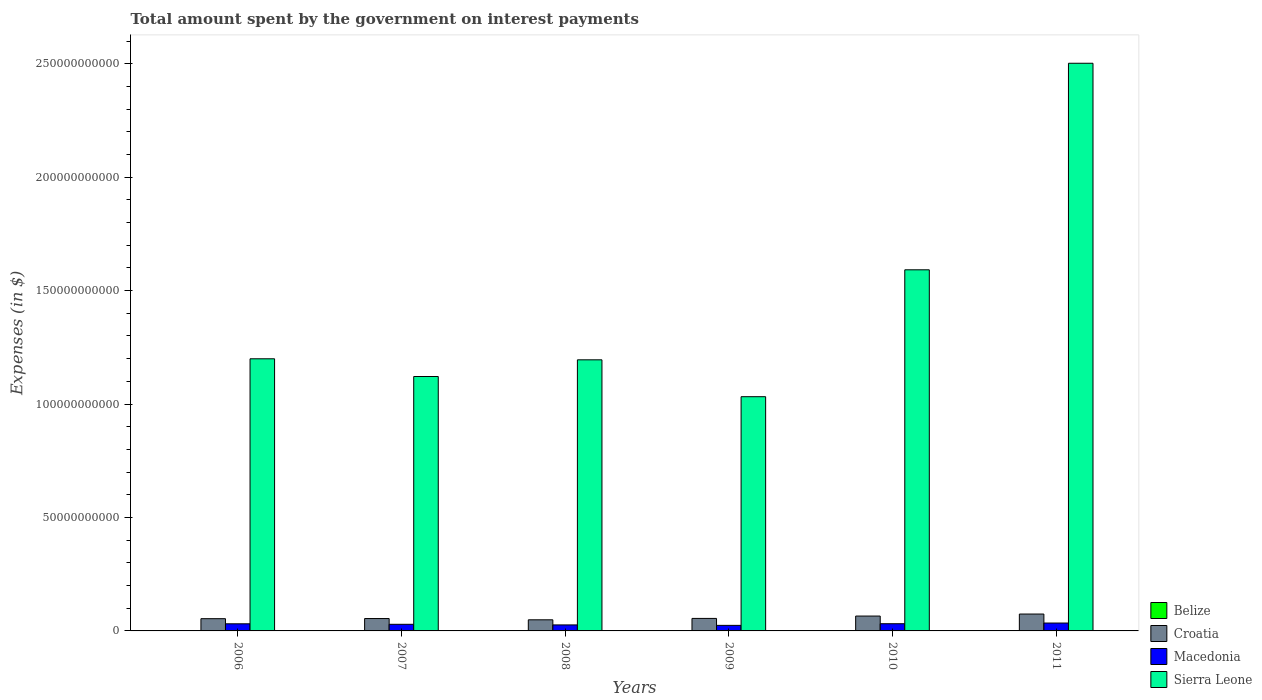How many different coloured bars are there?
Offer a terse response. 4. What is the label of the 6th group of bars from the left?
Provide a short and direct response. 2011. What is the amount spent on interest payments by the government in Sierra Leone in 2008?
Keep it short and to the point. 1.19e+11. Across all years, what is the maximum amount spent on interest payments by the government in Macedonia?
Your answer should be compact. 3.47e+09. Across all years, what is the minimum amount spent on interest payments by the government in Sierra Leone?
Your answer should be compact. 1.03e+11. In which year was the amount spent on interest payments by the government in Croatia maximum?
Give a very brief answer. 2011. What is the total amount spent on interest payments by the government in Croatia in the graph?
Give a very brief answer. 3.53e+1. What is the difference between the amount spent on interest payments by the government in Belize in 2007 and that in 2010?
Your answer should be compact. 7.81e+06. What is the difference between the amount spent on interest payments by the government in Croatia in 2007 and the amount spent on interest payments by the government in Macedonia in 2011?
Provide a short and direct response. 1.99e+09. What is the average amount spent on interest payments by the government in Macedonia per year?
Ensure brevity in your answer.  2.97e+09. In the year 2011, what is the difference between the amount spent on interest payments by the government in Croatia and amount spent on interest payments by the government in Macedonia?
Keep it short and to the point. 3.97e+09. In how many years, is the amount spent on interest payments by the government in Croatia greater than 200000000000 $?
Offer a very short reply. 0. What is the ratio of the amount spent on interest payments by the government in Belize in 2008 to that in 2011?
Give a very brief answer. 1. What is the difference between the highest and the second highest amount spent on interest payments by the government in Croatia?
Your answer should be very brief. 8.93e+08. What is the difference between the highest and the lowest amount spent on interest payments by the government in Croatia?
Keep it short and to the point. 2.54e+09. In how many years, is the amount spent on interest payments by the government in Belize greater than the average amount spent on interest payments by the government in Belize taken over all years?
Your response must be concise. 1. Is the sum of the amount spent on interest payments by the government in Sierra Leone in 2007 and 2008 greater than the maximum amount spent on interest payments by the government in Belize across all years?
Keep it short and to the point. Yes. Is it the case that in every year, the sum of the amount spent on interest payments by the government in Belize and amount spent on interest payments by the government in Sierra Leone is greater than the sum of amount spent on interest payments by the government in Croatia and amount spent on interest payments by the government in Macedonia?
Your answer should be very brief. Yes. What does the 2nd bar from the left in 2010 represents?
Ensure brevity in your answer.  Croatia. What does the 2nd bar from the right in 2006 represents?
Your answer should be compact. Macedonia. Are all the bars in the graph horizontal?
Make the answer very short. No. How many legend labels are there?
Provide a short and direct response. 4. What is the title of the graph?
Give a very brief answer. Total amount spent by the government on interest payments. Does "Djibouti" appear as one of the legend labels in the graph?
Your answer should be very brief. No. What is the label or title of the Y-axis?
Provide a short and direct response. Expenses (in $). What is the Expenses (in $) of Belize in 2006?
Make the answer very short. 1.70e+08. What is the Expenses (in $) in Croatia in 2006?
Your response must be concise. 5.40e+09. What is the Expenses (in $) in Macedonia in 2006?
Your response must be concise. 3.14e+09. What is the Expenses (in $) in Sierra Leone in 2006?
Offer a terse response. 1.20e+11. What is the Expenses (in $) in Belize in 2007?
Your answer should be very brief. 1.11e+08. What is the Expenses (in $) in Croatia in 2007?
Your response must be concise. 5.46e+09. What is the Expenses (in $) of Macedonia in 2007?
Ensure brevity in your answer.  2.92e+09. What is the Expenses (in $) of Sierra Leone in 2007?
Provide a succinct answer. 1.12e+11. What is the Expenses (in $) of Belize in 2008?
Offer a very short reply. 1.02e+08. What is the Expenses (in $) in Croatia in 2008?
Provide a succinct answer. 4.90e+09. What is the Expenses (in $) in Macedonia in 2008?
Ensure brevity in your answer.  2.65e+09. What is the Expenses (in $) of Sierra Leone in 2008?
Your answer should be very brief. 1.19e+11. What is the Expenses (in $) in Belize in 2009?
Make the answer very short. 9.58e+07. What is the Expenses (in $) in Croatia in 2009?
Your answer should be very brief. 5.51e+09. What is the Expenses (in $) in Macedonia in 2009?
Keep it short and to the point. 2.44e+09. What is the Expenses (in $) in Sierra Leone in 2009?
Ensure brevity in your answer.  1.03e+11. What is the Expenses (in $) in Belize in 2010?
Keep it short and to the point. 1.03e+08. What is the Expenses (in $) in Croatia in 2010?
Your answer should be compact. 6.55e+09. What is the Expenses (in $) in Macedonia in 2010?
Provide a short and direct response. 3.17e+09. What is the Expenses (in $) in Sierra Leone in 2010?
Your answer should be very brief. 1.59e+11. What is the Expenses (in $) of Belize in 2011?
Give a very brief answer. 1.02e+08. What is the Expenses (in $) in Croatia in 2011?
Your response must be concise. 7.44e+09. What is the Expenses (in $) in Macedonia in 2011?
Give a very brief answer. 3.47e+09. What is the Expenses (in $) in Sierra Leone in 2011?
Your response must be concise. 2.50e+11. Across all years, what is the maximum Expenses (in $) of Belize?
Your answer should be very brief. 1.70e+08. Across all years, what is the maximum Expenses (in $) in Croatia?
Offer a very short reply. 7.44e+09. Across all years, what is the maximum Expenses (in $) of Macedonia?
Your answer should be compact. 3.47e+09. Across all years, what is the maximum Expenses (in $) of Sierra Leone?
Offer a very short reply. 2.50e+11. Across all years, what is the minimum Expenses (in $) of Belize?
Your response must be concise. 9.58e+07. Across all years, what is the minimum Expenses (in $) in Croatia?
Your response must be concise. 4.90e+09. Across all years, what is the minimum Expenses (in $) in Macedonia?
Ensure brevity in your answer.  2.44e+09. Across all years, what is the minimum Expenses (in $) of Sierra Leone?
Offer a very short reply. 1.03e+11. What is the total Expenses (in $) of Belize in the graph?
Offer a very short reply. 6.85e+08. What is the total Expenses (in $) in Croatia in the graph?
Offer a very short reply. 3.53e+1. What is the total Expenses (in $) in Macedonia in the graph?
Offer a terse response. 1.78e+1. What is the total Expenses (in $) in Sierra Leone in the graph?
Offer a terse response. 8.64e+11. What is the difference between the Expenses (in $) in Belize in 2006 and that in 2007?
Keep it short and to the point. 5.90e+07. What is the difference between the Expenses (in $) in Croatia in 2006 and that in 2007?
Give a very brief answer. -6.40e+07. What is the difference between the Expenses (in $) in Macedonia in 2006 and that in 2007?
Offer a terse response. 2.22e+08. What is the difference between the Expenses (in $) in Sierra Leone in 2006 and that in 2007?
Give a very brief answer. 7.81e+09. What is the difference between the Expenses (in $) in Belize in 2006 and that in 2008?
Your answer should be compact. 6.79e+07. What is the difference between the Expenses (in $) of Croatia in 2006 and that in 2008?
Your answer should be very brief. 4.96e+08. What is the difference between the Expenses (in $) in Macedonia in 2006 and that in 2008?
Offer a terse response. 4.94e+08. What is the difference between the Expenses (in $) of Sierra Leone in 2006 and that in 2008?
Your answer should be compact. 4.59e+08. What is the difference between the Expenses (in $) of Belize in 2006 and that in 2009?
Your answer should be compact. 7.44e+07. What is the difference between the Expenses (in $) of Croatia in 2006 and that in 2009?
Ensure brevity in your answer.  -1.13e+08. What is the difference between the Expenses (in $) of Macedonia in 2006 and that in 2009?
Offer a very short reply. 6.95e+08. What is the difference between the Expenses (in $) in Sierra Leone in 2006 and that in 2009?
Offer a very short reply. 1.67e+1. What is the difference between the Expenses (in $) in Belize in 2006 and that in 2010?
Provide a succinct answer. 6.68e+07. What is the difference between the Expenses (in $) in Croatia in 2006 and that in 2010?
Give a very brief answer. -1.15e+09. What is the difference between the Expenses (in $) of Macedonia in 2006 and that in 2010?
Offer a very short reply. -3.39e+07. What is the difference between the Expenses (in $) in Sierra Leone in 2006 and that in 2010?
Keep it short and to the point. -3.92e+1. What is the difference between the Expenses (in $) of Belize in 2006 and that in 2011?
Provide a short and direct response. 6.79e+07. What is the difference between the Expenses (in $) of Croatia in 2006 and that in 2011?
Provide a succinct answer. -2.05e+09. What is the difference between the Expenses (in $) of Macedonia in 2006 and that in 2011?
Your response must be concise. -3.31e+08. What is the difference between the Expenses (in $) of Sierra Leone in 2006 and that in 2011?
Give a very brief answer. -1.30e+11. What is the difference between the Expenses (in $) of Belize in 2007 and that in 2008?
Keep it short and to the point. 8.84e+06. What is the difference between the Expenses (in $) of Croatia in 2007 and that in 2008?
Your answer should be compact. 5.60e+08. What is the difference between the Expenses (in $) in Macedonia in 2007 and that in 2008?
Make the answer very short. 2.72e+08. What is the difference between the Expenses (in $) of Sierra Leone in 2007 and that in 2008?
Offer a terse response. -7.35e+09. What is the difference between the Expenses (in $) in Belize in 2007 and that in 2009?
Offer a very short reply. 1.54e+07. What is the difference between the Expenses (in $) of Croatia in 2007 and that in 2009?
Ensure brevity in your answer.  -4.88e+07. What is the difference between the Expenses (in $) in Macedonia in 2007 and that in 2009?
Give a very brief answer. 4.73e+08. What is the difference between the Expenses (in $) of Sierra Leone in 2007 and that in 2009?
Your answer should be compact. 8.90e+09. What is the difference between the Expenses (in $) of Belize in 2007 and that in 2010?
Provide a short and direct response. 7.81e+06. What is the difference between the Expenses (in $) of Croatia in 2007 and that in 2010?
Give a very brief answer. -1.09e+09. What is the difference between the Expenses (in $) of Macedonia in 2007 and that in 2010?
Provide a short and direct response. -2.56e+08. What is the difference between the Expenses (in $) in Sierra Leone in 2007 and that in 2010?
Your response must be concise. -4.70e+1. What is the difference between the Expenses (in $) in Belize in 2007 and that in 2011?
Your response must be concise. 8.85e+06. What is the difference between the Expenses (in $) of Croatia in 2007 and that in 2011?
Provide a short and direct response. -1.98e+09. What is the difference between the Expenses (in $) of Macedonia in 2007 and that in 2011?
Your response must be concise. -5.53e+08. What is the difference between the Expenses (in $) of Sierra Leone in 2007 and that in 2011?
Keep it short and to the point. -1.38e+11. What is the difference between the Expenses (in $) of Belize in 2008 and that in 2009?
Your answer should be compact. 6.55e+06. What is the difference between the Expenses (in $) in Croatia in 2008 and that in 2009?
Provide a short and direct response. -6.09e+08. What is the difference between the Expenses (in $) in Macedonia in 2008 and that in 2009?
Provide a succinct answer. 2.01e+08. What is the difference between the Expenses (in $) of Sierra Leone in 2008 and that in 2009?
Your response must be concise. 1.62e+1. What is the difference between the Expenses (in $) in Belize in 2008 and that in 2010?
Offer a very short reply. -1.03e+06. What is the difference between the Expenses (in $) of Croatia in 2008 and that in 2010?
Keep it short and to the point. -1.65e+09. What is the difference between the Expenses (in $) in Macedonia in 2008 and that in 2010?
Provide a short and direct response. -5.28e+08. What is the difference between the Expenses (in $) in Sierra Leone in 2008 and that in 2010?
Keep it short and to the point. -3.97e+1. What is the difference between the Expenses (in $) of Belize in 2008 and that in 2011?
Make the answer very short. 2000. What is the difference between the Expenses (in $) in Croatia in 2008 and that in 2011?
Offer a terse response. -2.54e+09. What is the difference between the Expenses (in $) in Macedonia in 2008 and that in 2011?
Your answer should be compact. -8.25e+08. What is the difference between the Expenses (in $) in Sierra Leone in 2008 and that in 2011?
Offer a terse response. -1.31e+11. What is the difference between the Expenses (in $) of Belize in 2009 and that in 2010?
Make the answer very short. -7.59e+06. What is the difference between the Expenses (in $) of Croatia in 2009 and that in 2010?
Make the answer very short. -1.04e+09. What is the difference between the Expenses (in $) in Macedonia in 2009 and that in 2010?
Ensure brevity in your answer.  -7.29e+08. What is the difference between the Expenses (in $) in Sierra Leone in 2009 and that in 2010?
Ensure brevity in your answer.  -5.59e+1. What is the difference between the Expenses (in $) in Belize in 2009 and that in 2011?
Offer a terse response. -6.55e+06. What is the difference between the Expenses (in $) in Croatia in 2009 and that in 2011?
Make the answer very short. -1.93e+09. What is the difference between the Expenses (in $) in Macedonia in 2009 and that in 2011?
Provide a short and direct response. -1.03e+09. What is the difference between the Expenses (in $) of Sierra Leone in 2009 and that in 2011?
Provide a short and direct response. -1.47e+11. What is the difference between the Expenses (in $) of Belize in 2010 and that in 2011?
Make the answer very short. 1.03e+06. What is the difference between the Expenses (in $) of Croatia in 2010 and that in 2011?
Make the answer very short. -8.93e+08. What is the difference between the Expenses (in $) in Macedonia in 2010 and that in 2011?
Keep it short and to the point. -2.97e+08. What is the difference between the Expenses (in $) of Sierra Leone in 2010 and that in 2011?
Offer a very short reply. -9.10e+1. What is the difference between the Expenses (in $) in Belize in 2006 and the Expenses (in $) in Croatia in 2007?
Make the answer very short. -5.29e+09. What is the difference between the Expenses (in $) in Belize in 2006 and the Expenses (in $) in Macedonia in 2007?
Provide a short and direct response. -2.75e+09. What is the difference between the Expenses (in $) in Belize in 2006 and the Expenses (in $) in Sierra Leone in 2007?
Make the answer very short. -1.12e+11. What is the difference between the Expenses (in $) in Croatia in 2006 and the Expenses (in $) in Macedonia in 2007?
Make the answer very short. 2.48e+09. What is the difference between the Expenses (in $) in Croatia in 2006 and the Expenses (in $) in Sierra Leone in 2007?
Provide a short and direct response. -1.07e+11. What is the difference between the Expenses (in $) of Macedonia in 2006 and the Expenses (in $) of Sierra Leone in 2007?
Offer a terse response. -1.09e+11. What is the difference between the Expenses (in $) of Belize in 2006 and the Expenses (in $) of Croatia in 2008?
Keep it short and to the point. -4.73e+09. What is the difference between the Expenses (in $) of Belize in 2006 and the Expenses (in $) of Macedonia in 2008?
Provide a succinct answer. -2.48e+09. What is the difference between the Expenses (in $) of Belize in 2006 and the Expenses (in $) of Sierra Leone in 2008?
Ensure brevity in your answer.  -1.19e+11. What is the difference between the Expenses (in $) of Croatia in 2006 and the Expenses (in $) of Macedonia in 2008?
Ensure brevity in your answer.  2.75e+09. What is the difference between the Expenses (in $) in Croatia in 2006 and the Expenses (in $) in Sierra Leone in 2008?
Your answer should be compact. -1.14e+11. What is the difference between the Expenses (in $) of Macedonia in 2006 and the Expenses (in $) of Sierra Leone in 2008?
Make the answer very short. -1.16e+11. What is the difference between the Expenses (in $) of Belize in 2006 and the Expenses (in $) of Croatia in 2009?
Your answer should be very brief. -5.34e+09. What is the difference between the Expenses (in $) of Belize in 2006 and the Expenses (in $) of Macedonia in 2009?
Your response must be concise. -2.27e+09. What is the difference between the Expenses (in $) in Belize in 2006 and the Expenses (in $) in Sierra Leone in 2009?
Provide a succinct answer. -1.03e+11. What is the difference between the Expenses (in $) in Croatia in 2006 and the Expenses (in $) in Macedonia in 2009?
Your response must be concise. 2.95e+09. What is the difference between the Expenses (in $) of Croatia in 2006 and the Expenses (in $) of Sierra Leone in 2009?
Make the answer very short. -9.78e+1. What is the difference between the Expenses (in $) of Macedonia in 2006 and the Expenses (in $) of Sierra Leone in 2009?
Ensure brevity in your answer.  -1.00e+11. What is the difference between the Expenses (in $) in Belize in 2006 and the Expenses (in $) in Croatia in 2010?
Ensure brevity in your answer.  -6.38e+09. What is the difference between the Expenses (in $) of Belize in 2006 and the Expenses (in $) of Macedonia in 2010?
Make the answer very short. -3.00e+09. What is the difference between the Expenses (in $) of Belize in 2006 and the Expenses (in $) of Sierra Leone in 2010?
Provide a succinct answer. -1.59e+11. What is the difference between the Expenses (in $) in Croatia in 2006 and the Expenses (in $) in Macedonia in 2010?
Give a very brief answer. 2.22e+09. What is the difference between the Expenses (in $) of Croatia in 2006 and the Expenses (in $) of Sierra Leone in 2010?
Provide a short and direct response. -1.54e+11. What is the difference between the Expenses (in $) of Macedonia in 2006 and the Expenses (in $) of Sierra Leone in 2010?
Keep it short and to the point. -1.56e+11. What is the difference between the Expenses (in $) of Belize in 2006 and the Expenses (in $) of Croatia in 2011?
Offer a very short reply. -7.27e+09. What is the difference between the Expenses (in $) of Belize in 2006 and the Expenses (in $) of Macedonia in 2011?
Ensure brevity in your answer.  -3.30e+09. What is the difference between the Expenses (in $) in Belize in 2006 and the Expenses (in $) in Sierra Leone in 2011?
Your answer should be compact. -2.50e+11. What is the difference between the Expenses (in $) in Croatia in 2006 and the Expenses (in $) in Macedonia in 2011?
Ensure brevity in your answer.  1.93e+09. What is the difference between the Expenses (in $) of Croatia in 2006 and the Expenses (in $) of Sierra Leone in 2011?
Your response must be concise. -2.45e+11. What is the difference between the Expenses (in $) of Macedonia in 2006 and the Expenses (in $) of Sierra Leone in 2011?
Keep it short and to the point. -2.47e+11. What is the difference between the Expenses (in $) in Belize in 2007 and the Expenses (in $) in Croatia in 2008?
Keep it short and to the point. -4.79e+09. What is the difference between the Expenses (in $) of Belize in 2007 and the Expenses (in $) of Macedonia in 2008?
Offer a very short reply. -2.53e+09. What is the difference between the Expenses (in $) in Belize in 2007 and the Expenses (in $) in Sierra Leone in 2008?
Provide a succinct answer. -1.19e+11. What is the difference between the Expenses (in $) in Croatia in 2007 and the Expenses (in $) in Macedonia in 2008?
Offer a very short reply. 2.82e+09. What is the difference between the Expenses (in $) in Croatia in 2007 and the Expenses (in $) in Sierra Leone in 2008?
Your answer should be very brief. -1.14e+11. What is the difference between the Expenses (in $) in Macedonia in 2007 and the Expenses (in $) in Sierra Leone in 2008?
Your answer should be very brief. -1.17e+11. What is the difference between the Expenses (in $) of Belize in 2007 and the Expenses (in $) of Croatia in 2009?
Keep it short and to the point. -5.40e+09. What is the difference between the Expenses (in $) of Belize in 2007 and the Expenses (in $) of Macedonia in 2009?
Provide a short and direct response. -2.33e+09. What is the difference between the Expenses (in $) of Belize in 2007 and the Expenses (in $) of Sierra Leone in 2009?
Your answer should be very brief. -1.03e+11. What is the difference between the Expenses (in $) of Croatia in 2007 and the Expenses (in $) of Macedonia in 2009?
Provide a short and direct response. 3.02e+09. What is the difference between the Expenses (in $) of Croatia in 2007 and the Expenses (in $) of Sierra Leone in 2009?
Ensure brevity in your answer.  -9.78e+1. What is the difference between the Expenses (in $) in Macedonia in 2007 and the Expenses (in $) in Sierra Leone in 2009?
Provide a succinct answer. -1.00e+11. What is the difference between the Expenses (in $) in Belize in 2007 and the Expenses (in $) in Croatia in 2010?
Provide a succinct answer. -6.44e+09. What is the difference between the Expenses (in $) of Belize in 2007 and the Expenses (in $) of Macedonia in 2010?
Your answer should be very brief. -3.06e+09. What is the difference between the Expenses (in $) of Belize in 2007 and the Expenses (in $) of Sierra Leone in 2010?
Provide a short and direct response. -1.59e+11. What is the difference between the Expenses (in $) in Croatia in 2007 and the Expenses (in $) in Macedonia in 2010?
Your answer should be very brief. 2.29e+09. What is the difference between the Expenses (in $) of Croatia in 2007 and the Expenses (in $) of Sierra Leone in 2010?
Keep it short and to the point. -1.54e+11. What is the difference between the Expenses (in $) in Macedonia in 2007 and the Expenses (in $) in Sierra Leone in 2010?
Make the answer very short. -1.56e+11. What is the difference between the Expenses (in $) in Belize in 2007 and the Expenses (in $) in Croatia in 2011?
Your answer should be compact. -7.33e+09. What is the difference between the Expenses (in $) in Belize in 2007 and the Expenses (in $) in Macedonia in 2011?
Your response must be concise. -3.36e+09. What is the difference between the Expenses (in $) in Belize in 2007 and the Expenses (in $) in Sierra Leone in 2011?
Make the answer very short. -2.50e+11. What is the difference between the Expenses (in $) in Croatia in 2007 and the Expenses (in $) in Macedonia in 2011?
Provide a succinct answer. 1.99e+09. What is the difference between the Expenses (in $) of Croatia in 2007 and the Expenses (in $) of Sierra Leone in 2011?
Ensure brevity in your answer.  -2.45e+11. What is the difference between the Expenses (in $) of Macedonia in 2007 and the Expenses (in $) of Sierra Leone in 2011?
Offer a very short reply. -2.47e+11. What is the difference between the Expenses (in $) in Belize in 2008 and the Expenses (in $) in Croatia in 2009?
Your answer should be very brief. -5.41e+09. What is the difference between the Expenses (in $) in Belize in 2008 and the Expenses (in $) in Macedonia in 2009?
Your answer should be very brief. -2.34e+09. What is the difference between the Expenses (in $) of Belize in 2008 and the Expenses (in $) of Sierra Leone in 2009?
Keep it short and to the point. -1.03e+11. What is the difference between the Expenses (in $) of Croatia in 2008 and the Expenses (in $) of Macedonia in 2009?
Provide a short and direct response. 2.46e+09. What is the difference between the Expenses (in $) in Croatia in 2008 and the Expenses (in $) in Sierra Leone in 2009?
Make the answer very short. -9.83e+1. What is the difference between the Expenses (in $) of Macedonia in 2008 and the Expenses (in $) of Sierra Leone in 2009?
Give a very brief answer. -1.01e+11. What is the difference between the Expenses (in $) in Belize in 2008 and the Expenses (in $) in Croatia in 2010?
Keep it short and to the point. -6.45e+09. What is the difference between the Expenses (in $) in Belize in 2008 and the Expenses (in $) in Macedonia in 2010?
Your answer should be compact. -3.07e+09. What is the difference between the Expenses (in $) of Belize in 2008 and the Expenses (in $) of Sierra Leone in 2010?
Offer a very short reply. -1.59e+11. What is the difference between the Expenses (in $) in Croatia in 2008 and the Expenses (in $) in Macedonia in 2010?
Give a very brief answer. 1.73e+09. What is the difference between the Expenses (in $) in Croatia in 2008 and the Expenses (in $) in Sierra Leone in 2010?
Offer a very short reply. -1.54e+11. What is the difference between the Expenses (in $) in Macedonia in 2008 and the Expenses (in $) in Sierra Leone in 2010?
Provide a succinct answer. -1.57e+11. What is the difference between the Expenses (in $) of Belize in 2008 and the Expenses (in $) of Croatia in 2011?
Give a very brief answer. -7.34e+09. What is the difference between the Expenses (in $) of Belize in 2008 and the Expenses (in $) of Macedonia in 2011?
Offer a very short reply. -3.37e+09. What is the difference between the Expenses (in $) of Belize in 2008 and the Expenses (in $) of Sierra Leone in 2011?
Your answer should be compact. -2.50e+11. What is the difference between the Expenses (in $) in Croatia in 2008 and the Expenses (in $) in Macedonia in 2011?
Provide a succinct answer. 1.43e+09. What is the difference between the Expenses (in $) in Croatia in 2008 and the Expenses (in $) in Sierra Leone in 2011?
Ensure brevity in your answer.  -2.45e+11. What is the difference between the Expenses (in $) in Macedonia in 2008 and the Expenses (in $) in Sierra Leone in 2011?
Your response must be concise. -2.48e+11. What is the difference between the Expenses (in $) of Belize in 2009 and the Expenses (in $) of Croatia in 2010?
Ensure brevity in your answer.  -6.46e+09. What is the difference between the Expenses (in $) in Belize in 2009 and the Expenses (in $) in Macedonia in 2010?
Make the answer very short. -3.08e+09. What is the difference between the Expenses (in $) of Belize in 2009 and the Expenses (in $) of Sierra Leone in 2010?
Your answer should be very brief. -1.59e+11. What is the difference between the Expenses (in $) in Croatia in 2009 and the Expenses (in $) in Macedonia in 2010?
Ensure brevity in your answer.  2.34e+09. What is the difference between the Expenses (in $) in Croatia in 2009 and the Expenses (in $) in Sierra Leone in 2010?
Offer a terse response. -1.54e+11. What is the difference between the Expenses (in $) of Macedonia in 2009 and the Expenses (in $) of Sierra Leone in 2010?
Offer a terse response. -1.57e+11. What is the difference between the Expenses (in $) in Belize in 2009 and the Expenses (in $) in Croatia in 2011?
Your answer should be very brief. -7.35e+09. What is the difference between the Expenses (in $) of Belize in 2009 and the Expenses (in $) of Macedonia in 2011?
Offer a terse response. -3.38e+09. What is the difference between the Expenses (in $) of Belize in 2009 and the Expenses (in $) of Sierra Leone in 2011?
Make the answer very short. -2.50e+11. What is the difference between the Expenses (in $) of Croatia in 2009 and the Expenses (in $) of Macedonia in 2011?
Provide a succinct answer. 2.04e+09. What is the difference between the Expenses (in $) in Croatia in 2009 and the Expenses (in $) in Sierra Leone in 2011?
Provide a short and direct response. -2.45e+11. What is the difference between the Expenses (in $) of Macedonia in 2009 and the Expenses (in $) of Sierra Leone in 2011?
Ensure brevity in your answer.  -2.48e+11. What is the difference between the Expenses (in $) of Belize in 2010 and the Expenses (in $) of Croatia in 2011?
Provide a short and direct response. -7.34e+09. What is the difference between the Expenses (in $) of Belize in 2010 and the Expenses (in $) of Macedonia in 2011?
Keep it short and to the point. -3.37e+09. What is the difference between the Expenses (in $) in Belize in 2010 and the Expenses (in $) in Sierra Leone in 2011?
Ensure brevity in your answer.  -2.50e+11. What is the difference between the Expenses (in $) in Croatia in 2010 and the Expenses (in $) in Macedonia in 2011?
Offer a terse response. 3.08e+09. What is the difference between the Expenses (in $) of Croatia in 2010 and the Expenses (in $) of Sierra Leone in 2011?
Offer a terse response. -2.44e+11. What is the difference between the Expenses (in $) of Macedonia in 2010 and the Expenses (in $) of Sierra Leone in 2011?
Give a very brief answer. -2.47e+11. What is the average Expenses (in $) of Belize per year?
Provide a short and direct response. 1.14e+08. What is the average Expenses (in $) of Croatia per year?
Offer a terse response. 5.88e+09. What is the average Expenses (in $) in Macedonia per year?
Offer a terse response. 2.97e+09. What is the average Expenses (in $) of Sierra Leone per year?
Give a very brief answer. 1.44e+11. In the year 2006, what is the difference between the Expenses (in $) of Belize and Expenses (in $) of Croatia?
Your response must be concise. -5.23e+09. In the year 2006, what is the difference between the Expenses (in $) in Belize and Expenses (in $) in Macedonia?
Give a very brief answer. -2.97e+09. In the year 2006, what is the difference between the Expenses (in $) of Belize and Expenses (in $) of Sierra Leone?
Your answer should be compact. -1.20e+11. In the year 2006, what is the difference between the Expenses (in $) in Croatia and Expenses (in $) in Macedonia?
Make the answer very short. 2.26e+09. In the year 2006, what is the difference between the Expenses (in $) of Croatia and Expenses (in $) of Sierra Leone?
Give a very brief answer. -1.15e+11. In the year 2006, what is the difference between the Expenses (in $) of Macedonia and Expenses (in $) of Sierra Leone?
Offer a terse response. -1.17e+11. In the year 2007, what is the difference between the Expenses (in $) in Belize and Expenses (in $) in Croatia?
Your answer should be very brief. -5.35e+09. In the year 2007, what is the difference between the Expenses (in $) of Belize and Expenses (in $) of Macedonia?
Provide a succinct answer. -2.81e+09. In the year 2007, what is the difference between the Expenses (in $) of Belize and Expenses (in $) of Sierra Leone?
Ensure brevity in your answer.  -1.12e+11. In the year 2007, what is the difference between the Expenses (in $) in Croatia and Expenses (in $) in Macedonia?
Your response must be concise. 2.54e+09. In the year 2007, what is the difference between the Expenses (in $) in Croatia and Expenses (in $) in Sierra Leone?
Provide a short and direct response. -1.07e+11. In the year 2007, what is the difference between the Expenses (in $) in Macedonia and Expenses (in $) in Sierra Leone?
Your answer should be very brief. -1.09e+11. In the year 2008, what is the difference between the Expenses (in $) of Belize and Expenses (in $) of Croatia?
Your answer should be compact. -4.80e+09. In the year 2008, what is the difference between the Expenses (in $) of Belize and Expenses (in $) of Macedonia?
Offer a terse response. -2.54e+09. In the year 2008, what is the difference between the Expenses (in $) of Belize and Expenses (in $) of Sierra Leone?
Your answer should be compact. -1.19e+11. In the year 2008, what is the difference between the Expenses (in $) in Croatia and Expenses (in $) in Macedonia?
Provide a succinct answer. 2.26e+09. In the year 2008, what is the difference between the Expenses (in $) in Croatia and Expenses (in $) in Sierra Leone?
Offer a terse response. -1.15e+11. In the year 2008, what is the difference between the Expenses (in $) of Macedonia and Expenses (in $) of Sierra Leone?
Provide a short and direct response. -1.17e+11. In the year 2009, what is the difference between the Expenses (in $) of Belize and Expenses (in $) of Croatia?
Provide a short and direct response. -5.41e+09. In the year 2009, what is the difference between the Expenses (in $) of Belize and Expenses (in $) of Macedonia?
Your answer should be compact. -2.35e+09. In the year 2009, what is the difference between the Expenses (in $) of Belize and Expenses (in $) of Sierra Leone?
Make the answer very short. -1.03e+11. In the year 2009, what is the difference between the Expenses (in $) in Croatia and Expenses (in $) in Macedonia?
Give a very brief answer. 3.06e+09. In the year 2009, what is the difference between the Expenses (in $) of Croatia and Expenses (in $) of Sierra Leone?
Offer a very short reply. -9.77e+1. In the year 2009, what is the difference between the Expenses (in $) in Macedonia and Expenses (in $) in Sierra Leone?
Provide a short and direct response. -1.01e+11. In the year 2010, what is the difference between the Expenses (in $) of Belize and Expenses (in $) of Croatia?
Your response must be concise. -6.45e+09. In the year 2010, what is the difference between the Expenses (in $) of Belize and Expenses (in $) of Macedonia?
Provide a short and direct response. -3.07e+09. In the year 2010, what is the difference between the Expenses (in $) of Belize and Expenses (in $) of Sierra Leone?
Offer a very short reply. -1.59e+11. In the year 2010, what is the difference between the Expenses (in $) of Croatia and Expenses (in $) of Macedonia?
Offer a terse response. 3.38e+09. In the year 2010, what is the difference between the Expenses (in $) in Croatia and Expenses (in $) in Sierra Leone?
Offer a very short reply. -1.53e+11. In the year 2010, what is the difference between the Expenses (in $) of Macedonia and Expenses (in $) of Sierra Leone?
Offer a very short reply. -1.56e+11. In the year 2011, what is the difference between the Expenses (in $) in Belize and Expenses (in $) in Croatia?
Offer a very short reply. -7.34e+09. In the year 2011, what is the difference between the Expenses (in $) of Belize and Expenses (in $) of Macedonia?
Offer a terse response. -3.37e+09. In the year 2011, what is the difference between the Expenses (in $) of Belize and Expenses (in $) of Sierra Leone?
Ensure brevity in your answer.  -2.50e+11. In the year 2011, what is the difference between the Expenses (in $) in Croatia and Expenses (in $) in Macedonia?
Provide a short and direct response. 3.97e+09. In the year 2011, what is the difference between the Expenses (in $) in Croatia and Expenses (in $) in Sierra Leone?
Provide a short and direct response. -2.43e+11. In the year 2011, what is the difference between the Expenses (in $) in Macedonia and Expenses (in $) in Sierra Leone?
Your answer should be very brief. -2.47e+11. What is the ratio of the Expenses (in $) in Belize in 2006 to that in 2007?
Your answer should be compact. 1.53. What is the ratio of the Expenses (in $) in Croatia in 2006 to that in 2007?
Keep it short and to the point. 0.99. What is the ratio of the Expenses (in $) of Macedonia in 2006 to that in 2007?
Offer a terse response. 1.08. What is the ratio of the Expenses (in $) in Sierra Leone in 2006 to that in 2007?
Keep it short and to the point. 1.07. What is the ratio of the Expenses (in $) of Belize in 2006 to that in 2008?
Your answer should be very brief. 1.66. What is the ratio of the Expenses (in $) in Croatia in 2006 to that in 2008?
Your response must be concise. 1.1. What is the ratio of the Expenses (in $) of Macedonia in 2006 to that in 2008?
Your response must be concise. 1.19. What is the ratio of the Expenses (in $) in Belize in 2006 to that in 2009?
Provide a succinct answer. 1.78. What is the ratio of the Expenses (in $) of Croatia in 2006 to that in 2009?
Keep it short and to the point. 0.98. What is the ratio of the Expenses (in $) of Macedonia in 2006 to that in 2009?
Offer a very short reply. 1.28. What is the ratio of the Expenses (in $) of Sierra Leone in 2006 to that in 2009?
Your answer should be very brief. 1.16. What is the ratio of the Expenses (in $) of Belize in 2006 to that in 2010?
Your answer should be compact. 1.65. What is the ratio of the Expenses (in $) in Croatia in 2006 to that in 2010?
Give a very brief answer. 0.82. What is the ratio of the Expenses (in $) of Macedonia in 2006 to that in 2010?
Give a very brief answer. 0.99. What is the ratio of the Expenses (in $) of Sierra Leone in 2006 to that in 2010?
Your answer should be compact. 0.75. What is the ratio of the Expenses (in $) of Belize in 2006 to that in 2011?
Your answer should be very brief. 1.66. What is the ratio of the Expenses (in $) in Croatia in 2006 to that in 2011?
Offer a very short reply. 0.72. What is the ratio of the Expenses (in $) of Macedonia in 2006 to that in 2011?
Make the answer very short. 0.9. What is the ratio of the Expenses (in $) of Sierra Leone in 2006 to that in 2011?
Give a very brief answer. 0.48. What is the ratio of the Expenses (in $) of Belize in 2007 to that in 2008?
Offer a terse response. 1.09. What is the ratio of the Expenses (in $) of Croatia in 2007 to that in 2008?
Your answer should be compact. 1.11. What is the ratio of the Expenses (in $) of Macedonia in 2007 to that in 2008?
Give a very brief answer. 1.1. What is the ratio of the Expenses (in $) of Sierra Leone in 2007 to that in 2008?
Provide a short and direct response. 0.94. What is the ratio of the Expenses (in $) in Belize in 2007 to that in 2009?
Your response must be concise. 1.16. What is the ratio of the Expenses (in $) in Macedonia in 2007 to that in 2009?
Provide a short and direct response. 1.19. What is the ratio of the Expenses (in $) of Sierra Leone in 2007 to that in 2009?
Offer a terse response. 1.09. What is the ratio of the Expenses (in $) in Belize in 2007 to that in 2010?
Offer a terse response. 1.08. What is the ratio of the Expenses (in $) in Croatia in 2007 to that in 2010?
Offer a very short reply. 0.83. What is the ratio of the Expenses (in $) of Macedonia in 2007 to that in 2010?
Ensure brevity in your answer.  0.92. What is the ratio of the Expenses (in $) of Sierra Leone in 2007 to that in 2010?
Your answer should be very brief. 0.7. What is the ratio of the Expenses (in $) in Belize in 2007 to that in 2011?
Offer a terse response. 1.09. What is the ratio of the Expenses (in $) of Croatia in 2007 to that in 2011?
Give a very brief answer. 0.73. What is the ratio of the Expenses (in $) of Macedonia in 2007 to that in 2011?
Give a very brief answer. 0.84. What is the ratio of the Expenses (in $) of Sierra Leone in 2007 to that in 2011?
Your answer should be compact. 0.45. What is the ratio of the Expenses (in $) of Belize in 2008 to that in 2009?
Your answer should be compact. 1.07. What is the ratio of the Expenses (in $) of Croatia in 2008 to that in 2009?
Give a very brief answer. 0.89. What is the ratio of the Expenses (in $) in Macedonia in 2008 to that in 2009?
Give a very brief answer. 1.08. What is the ratio of the Expenses (in $) of Sierra Leone in 2008 to that in 2009?
Keep it short and to the point. 1.16. What is the ratio of the Expenses (in $) in Belize in 2008 to that in 2010?
Offer a terse response. 0.99. What is the ratio of the Expenses (in $) of Croatia in 2008 to that in 2010?
Provide a succinct answer. 0.75. What is the ratio of the Expenses (in $) in Macedonia in 2008 to that in 2010?
Provide a short and direct response. 0.83. What is the ratio of the Expenses (in $) in Sierra Leone in 2008 to that in 2010?
Your answer should be very brief. 0.75. What is the ratio of the Expenses (in $) of Belize in 2008 to that in 2011?
Your answer should be compact. 1. What is the ratio of the Expenses (in $) in Croatia in 2008 to that in 2011?
Ensure brevity in your answer.  0.66. What is the ratio of the Expenses (in $) of Macedonia in 2008 to that in 2011?
Give a very brief answer. 0.76. What is the ratio of the Expenses (in $) in Sierra Leone in 2008 to that in 2011?
Your answer should be very brief. 0.48. What is the ratio of the Expenses (in $) in Belize in 2009 to that in 2010?
Provide a succinct answer. 0.93. What is the ratio of the Expenses (in $) of Croatia in 2009 to that in 2010?
Provide a short and direct response. 0.84. What is the ratio of the Expenses (in $) in Macedonia in 2009 to that in 2010?
Make the answer very short. 0.77. What is the ratio of the Expenses (in $) of Sierra Leone in 2009 to that in 2010?
Keep it short and to the point. 0.65. What is the ratio of the Expenses (in $) in Belize in 2009 to that in 2011?
Your answer should be very brief. 0.94. What is the ratio of the Expenses (in $) in Croatia in 2009 to that in 2011?
Offer a terse response. 0.74. What is the ratio of the Expenses (in $) in Macedonia in 2009 to that in 2011?
Provide a short and direct response. 0.7. What is the ratio of the Expenses (in $) in Sierra Leone in 2009 to that in 2011?
Your answer should be compact. 0.41. What is the ratio of the Expenses (in $) in Croatia in 2010 to that in 2011?
Offer a very short reply. 0.88. What is the ratio of the Expenses (in $) in Macedonia in 2010 to that in 2011?
Your answer should be very brief. 0.91. What is the ratio of the Expenses (in $) of Sierra Leone in 2010 to that in 2011?
Ensure brevity in your answer.  0.64. What is the difference between the highest and the second highest Expenses (in $) in Belize?
Your answer should be compact. 5.90e+07. What is the difference between the highest and the second highest Expenses (in $) in Croatia?
Provide a short and direct response. 8.93e+08. What is the difference between the highest and the second highest Expenses (in $) of Macedonia?
Offer a very short reply. 2.97e+08. What is the difference between the highest and the second highest Expenses (in $) of Sierra Leone?
Keep it short and to the point. 9.10e+1. What is the difference between the highest and the lowest Expenses (in $) in Belize?
Ensure brevity in your answer.  7.44e+07. What is the difference between the highest and the lowest Expenses (in $) in Croatia?
Your answer should be compact. 2.54e+09. What is the difference between the highest and the lowest Expenses (in $) of Macedonia?
Offer a very short reply. 1.03e+09. What is the difference between the highest and the lowest Expenses (in $) of Sierra Leone?
Your answer should be very brief. 1.47e+11. 